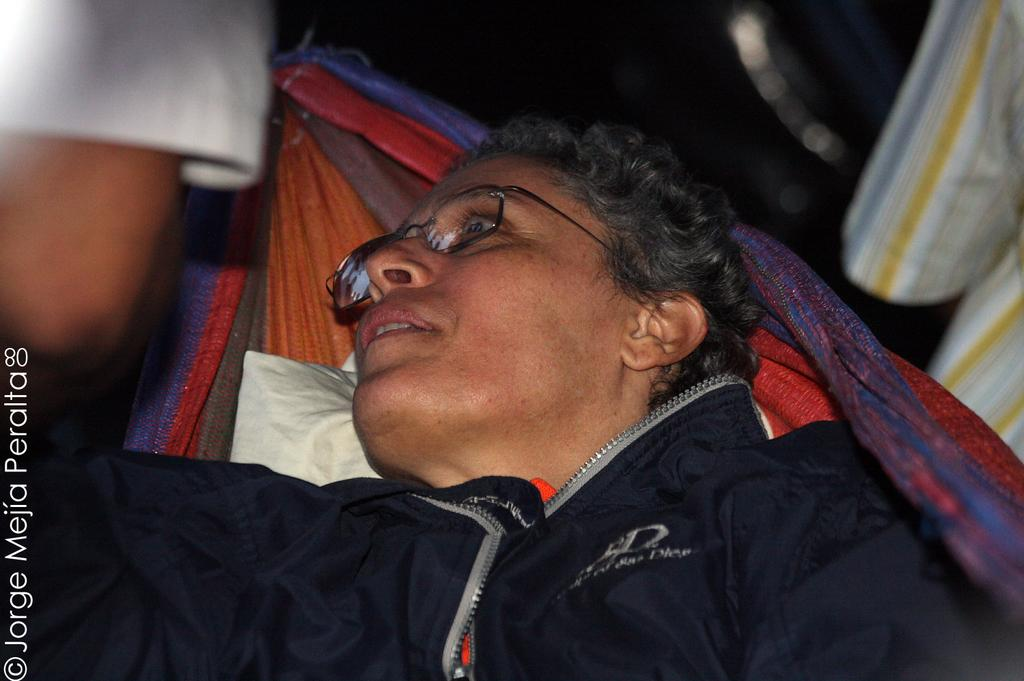What is the person in the image doing? The person is lying on a cloth in the image. What colors are present on the cloth? The cloth has red and purple colors. What is the person wearing? The person is wearing a black jacket. How would you describe the background of the image? The background of the image is blurred. What type of zephyr can be seen blowing in the image? There is no zephyr present in the image. How much does the person weigh on a scale in the image? There is no scale present in the image, so it is impossible to determine the person's weight. 